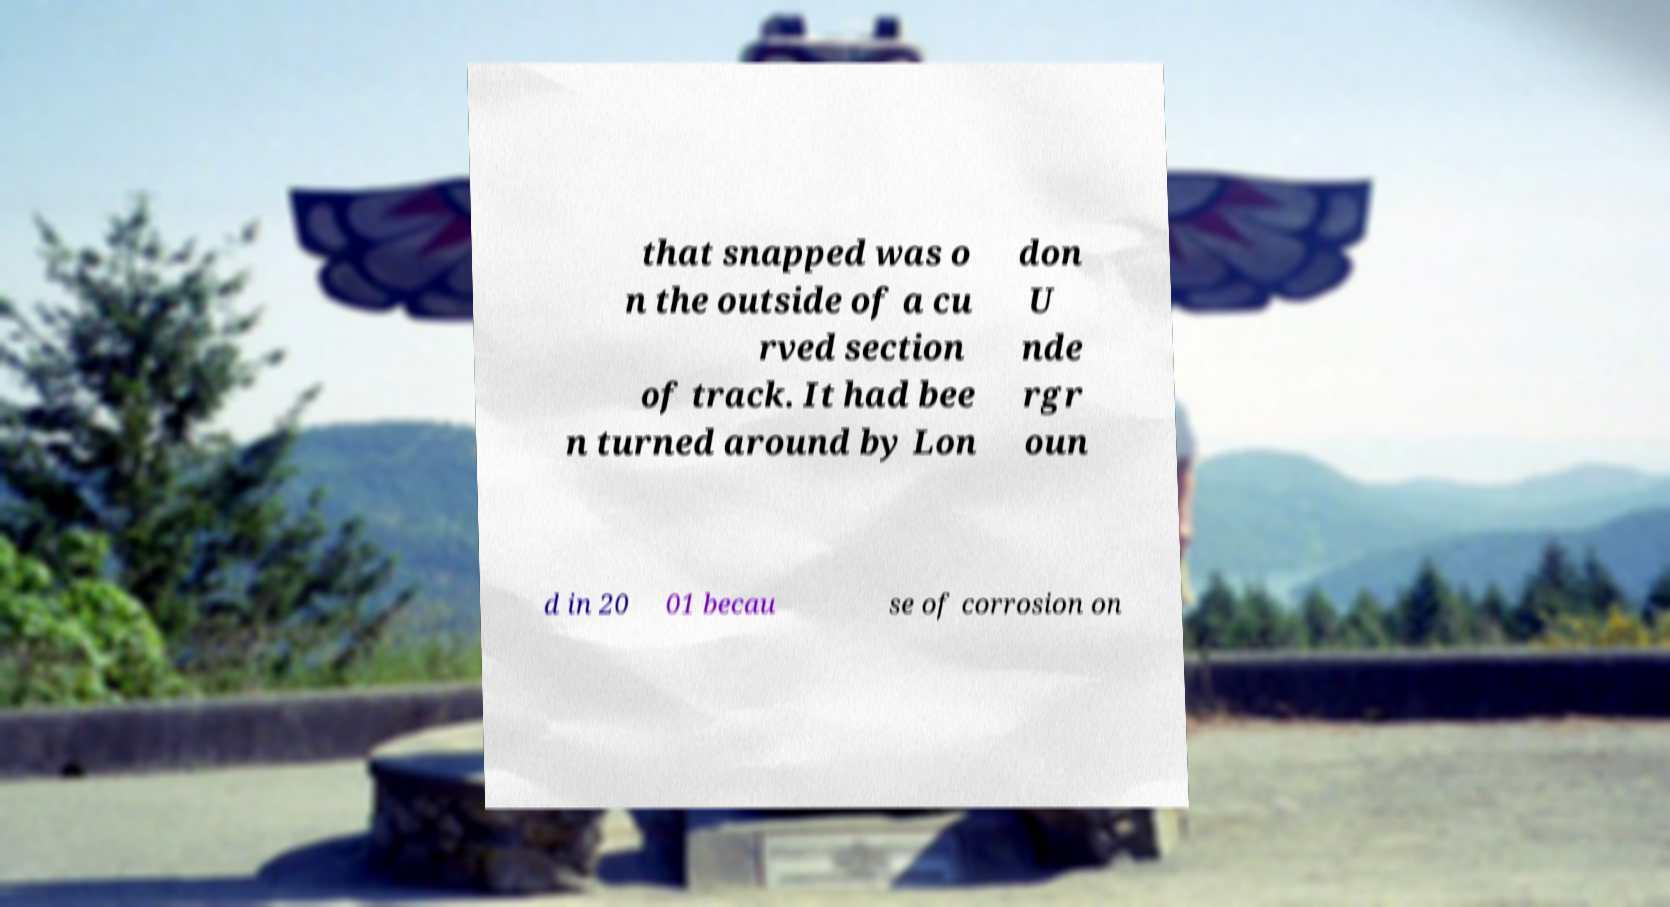Could you assist in decoding the text presented in this image and type it out clearly? that snapped was o n the outside of a cu rved section of track. It had bee n turned around by Lon don U nde rgr oun d in 20 01 becau se of corrosion on 